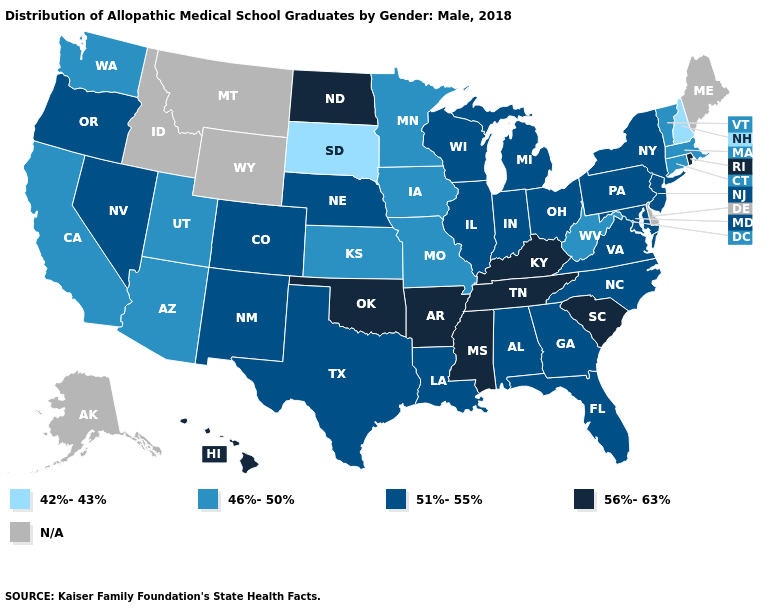Name the states that have a value in the range N/A?
Write a very short answer. Alaska, Delaware, Idaho, Maine, Montana, Wyoming. Which states have the lowest value in the USA?
Answer briefly. New Hampshire, South Dakota. Name the states that have a value in the range 46%-50%?
Short answer required. Arizona, California, Connecticut, Iowa, Kansas, Massachusetts, Minnesota, Missouri, Utah, Vermont, Washington, West Virginia. What is the highest value in the West ?
Be succinct. 56%-63%. Which states hav the highest value in the Northeast?
Short answer required. Rhode Island. What is the value of Tennessee?
Give a very brief answer. 56%-63%. What is the highest value in the USA?
Quick response, please. 56%-63%. Name the states that have a value in the range 56%-63%?
Quick response, please. Arkansas, Hawaii, Kentucky, Mississippi, North Dakota, Oklahoma, Rhode Island, South Carolina, Tennessee. What is the lowest value in the USA?
Be succinct. 42%-43%. Among the states that border Alabama , which have the highest value?
Answer briefly. Mississippi, Tennessee. Does West Virginia have the highest value in the USA?
Concise answer only. No. Name the states that have a value in the range 46%-50%?
Short answer required. Arizona, California, Connecticut, Iowa, Kansas, Massachusetts, Minnesota, Missouri, Utah, Vermont, Washington, West Virginia. Name the states that have a value in the range N/A?
Answer briefly. Alaska, Delaware, Idaho, Maine, Montana, Wyoming. What is the value of New Hampshire?
Answer briefly. 42%-43%. Name the states that have a value in the range 42%-43%?
Quick response, please. New Hampshire, South Dakota. 